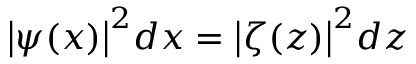Convert formula to latex. <formula><loc_0><loc_0><loc_500><loc_500>{ \left | \psi ( x ) \right | } ^ { 2 } d x = { \left | \zeta ( z ) \right | } ^ { 2 } d z</formula> 